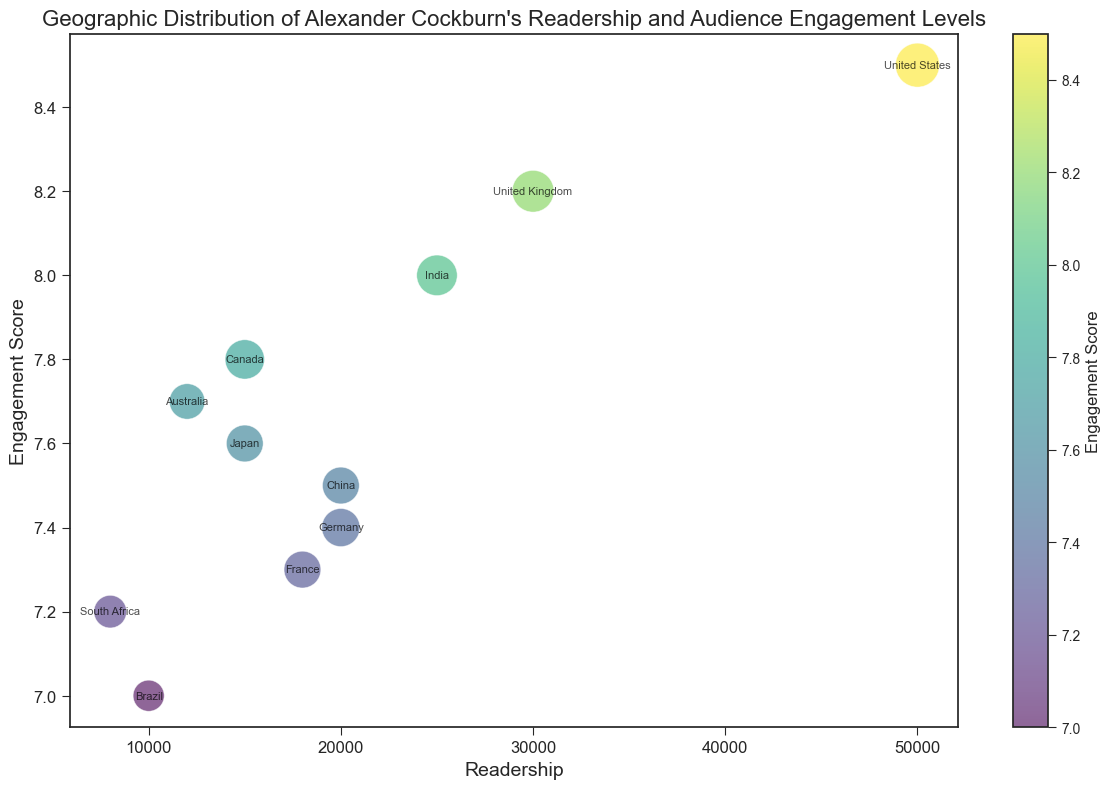What's the country with the highest readership? Look for the largest value on the x-axis representing readership. The United States has the highest readership value at 50,000.
Answer: United States Which country has a higher engagement score, Canada or Japan? Compare the vertical positions of Canada and Japan. Canada has an engagement score of 7.8 while Japan has 7.6, thus Canada has a higher score.
Answer: Canada Which region has the smallest bubble size but still appears in the chart? Look for the smallest bubbles in the figure. The smallest bubble size that still appears belongs to South Africa in the Africa region with a size of 5.5.
Answer: Africa Is the engagement score of the United Kingdom higher or lower than that of Germany? Check the vertical positions of the United Kingdom and Germany. The engagement score for the United Kingdom is 8.2, which is higher than Germany's 7.4.
Answer: Higher What is the average readership of countries in the Europe region? Sum the readerships of the United Kingdom, Germany, and France: 30,000 + 20,000 + 18,000 = 68,000. There are three countries, so the average is 68,000 / 3 = 22,667.
Answer: 22,667 Which country has the darkest colored bubble, and what does that color represent? The bubble's color reflects the engagement score, and the darkest bubble corresponds to the highest engagement score. The United States, with an engagement score of 8.5, has the darkest-colored bubble.
Answer: United States, high engagement score (8.5) Among the Asian countries listed, which one has the highest readership? Compare the readership values of India, Japan, and China. India has the highest readership at 25,000.
Answer: India Are there more countries with an engagement score above 8.0 or below 8.0? Count the number of countries with scores above and below 8.0. Above 8.0: United States, United Kingdom, India (3 countries). Below 8.0: Canada, Germany, France, Brazil, Japan, China, Australia, South Africa (8 countries). Thus, there are more countries below 8.0.
Answer: Below 8.0 What is the sum of the engagement scores for countries in the North America region? Sum the engagement scores of the United States and Canada: 8.5 + 7.8 = 16.3.
Answer: 16.3 